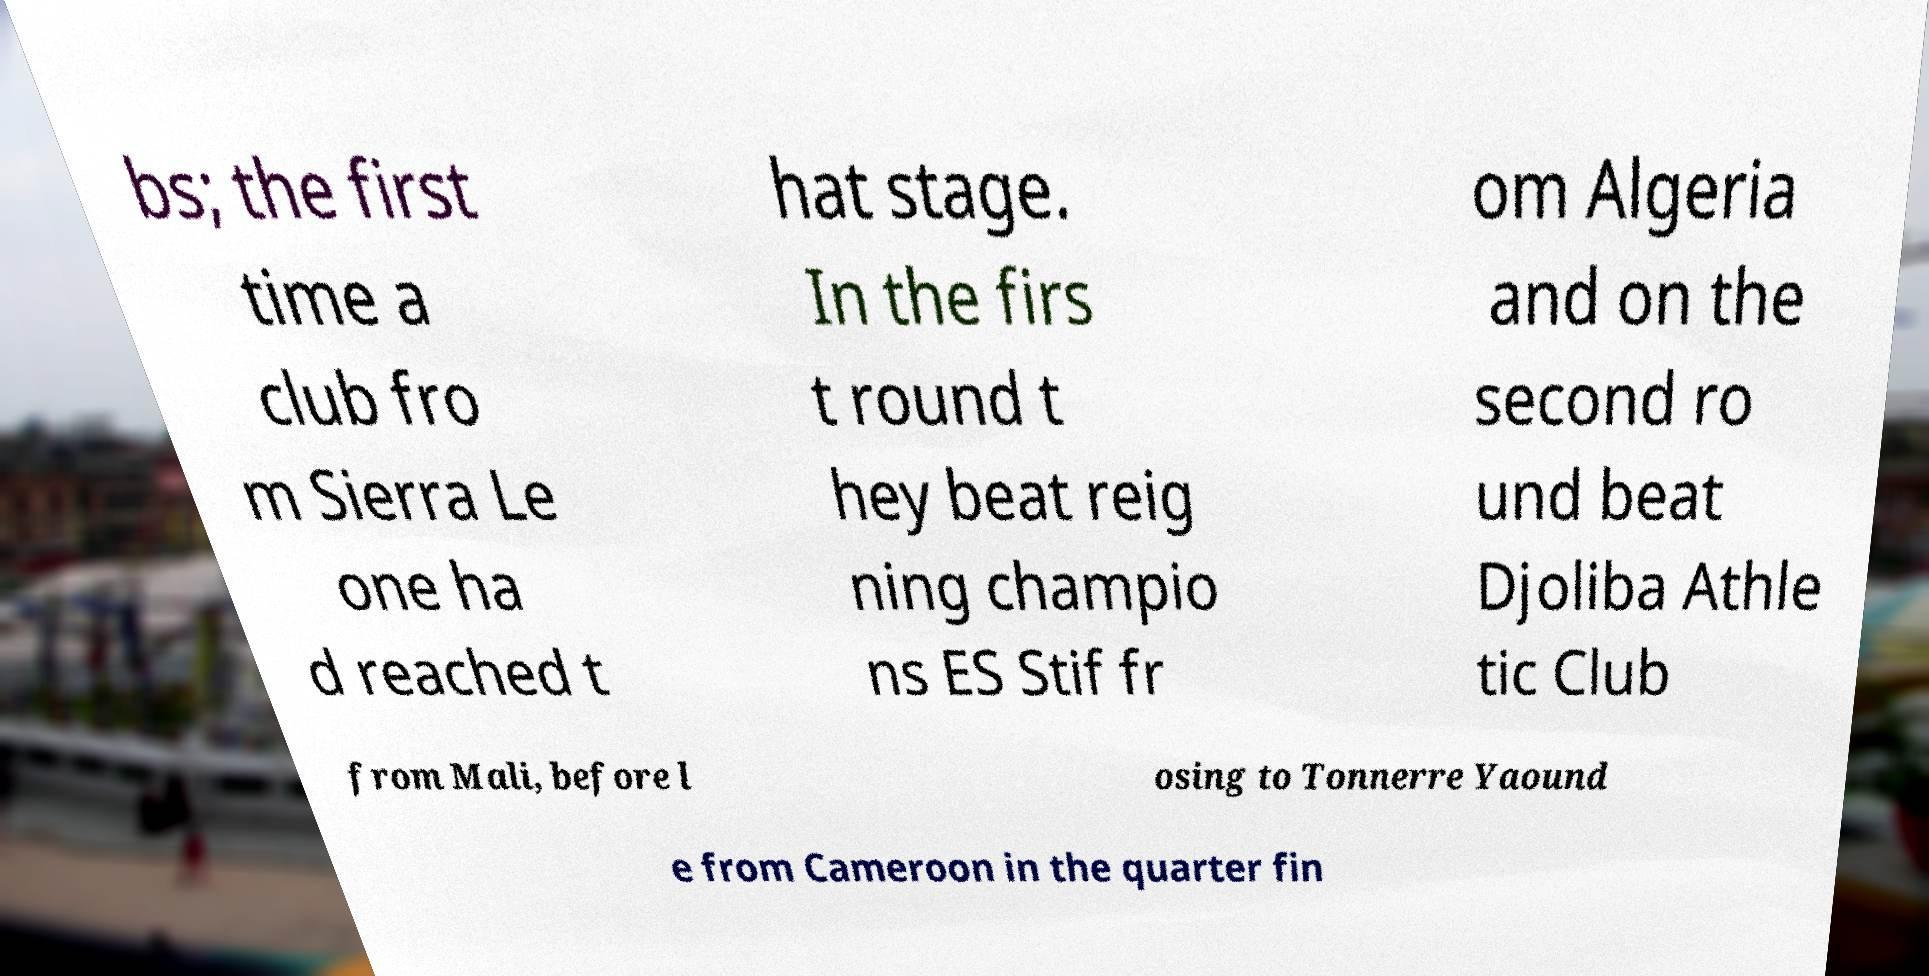What messages or text are displayed in this image? I need them in a readable, typed format. bs; the first time a club fro m Sierra Le one ha d reached t hat stage. In the firs t round t hey beat reig ning champio ns ES Stif fr om Algeria and on the second ro und beat Djoliba Athle tic Club from Mali, before l osing to Tonnerre Yaound e from Cameroon in the quarter fin 